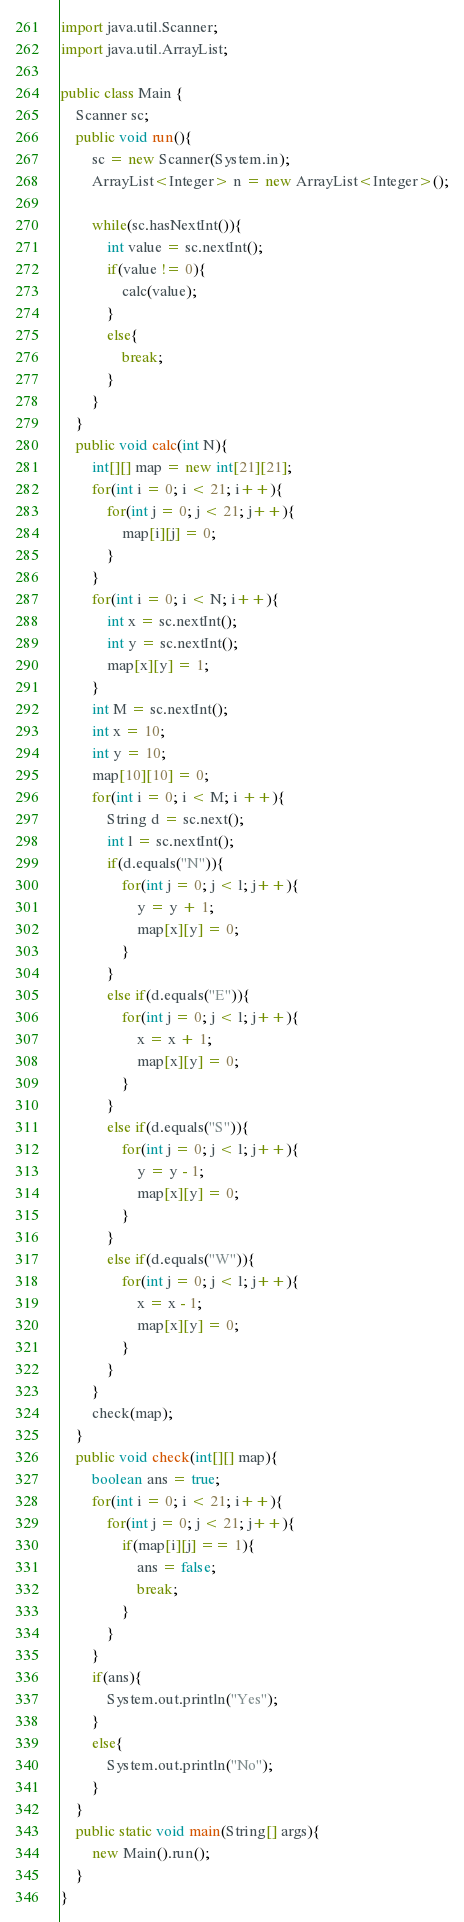<code> <loc_0><loc_0><loc_500><loc_500><_Java_>import java.util.Scanner;
import java.util.ArrayList;

public class Main {
	Scanner sc;
	public void run(){
		sc = new Scanner(System.in);
		ArrayList<Integer> n = new ArrayList<Integer>();

		while(sc.hasNextInt()){
			int value = sc.nextInt();
			if(value != 0){
				calc(value);
			}
			else{
				break;
			}
		}
	}
	public void calc(int N){
		int[][] map = new int[21][21];
		for(int i = 0; i < 21; i++){
			for(int j = 0; j < 21; j++){
				map[i][j] = 0;
			}
		}
		for(int i = 0; i < N; i++){
			int x = sc.nextInt();
			int y = sc.nextInt();
			map[x][y] = 1;
		}
		int M = sc.nextInt();
		int x = 10;
		int y = 10;
		map[10][10] = 0;
		for(int i = 0; i < M; i ++){
			String d = sc.next();
			int l = sc.nextInt();
			if(d.equals("N")){
				for(int j = 0; j < l; j++){
					y = y + 1;
					map[x][y] = 0;
				}
			}
			else if(d.equals("E")){
				for(int j = 0; j < l; j++){
					x = x + 1;
					map[x][y] = 0;
				}
			}
			else if(d.equals("S")){
				for(int j = 0; j < l; j++){
					y = y - 1;
					map[x][y] = 0;
				}
			}
			else if(d.equals("W")){
				for(int j = 0; j < l; j++){
					x = x - 1;
					map[x][y] = 0;
				}
			}
		}
		check(map);
	}
	public void check(int[][] map){
		boolean ans = true;
		for(int i = 0; i < 21; i++){
			for(int j = 0; j < 21; j++){
				if(map[i][j] == 1){
					ans = false;
					break;
				}
			}
		}
		if(ans){
			System.out.println("Yes");
		}
		else{
			System.out.println("No");
		}
	}
	public static void main(String[] args){
		new Main().run();
	}
}</code> 